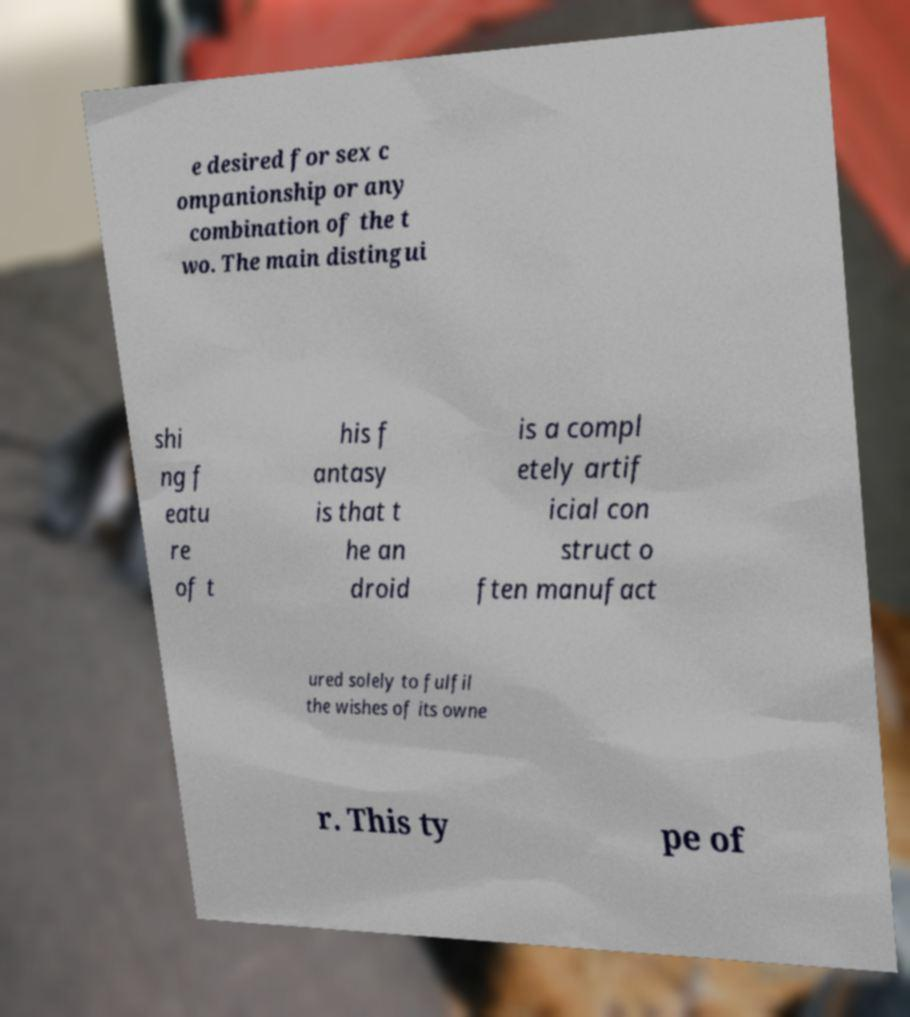Can you accurately transcribe the text from the provided image for me? e desired for sex c ompanionship or any combination of the t wo. The main distingui shi ng f eatu re of t his f antasy is that t he an droid is a compl etely artif icial con struct o ften manufact ured solely to fulfil the wishes of its owne r. This ty pe of 